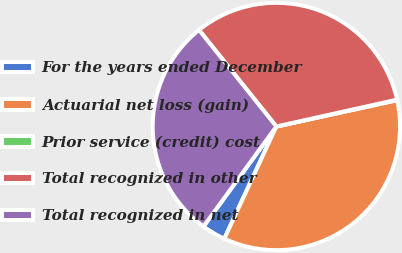Convert chart to OTSL. <chart><loc_0><loc_0><loc_500><loc_500><pie_chart><fcel>For the years ended December<fcel>Actuarial net loss (gain)<fcel>Prior service (credit) cost<fcel>Total recognized in other<fcel>Total recognized in net<nl><fcel>3.11%<fcel>35.32%<fcel>0.07%<fcel>32.27%<fcel>29.23%<nl></chart> 